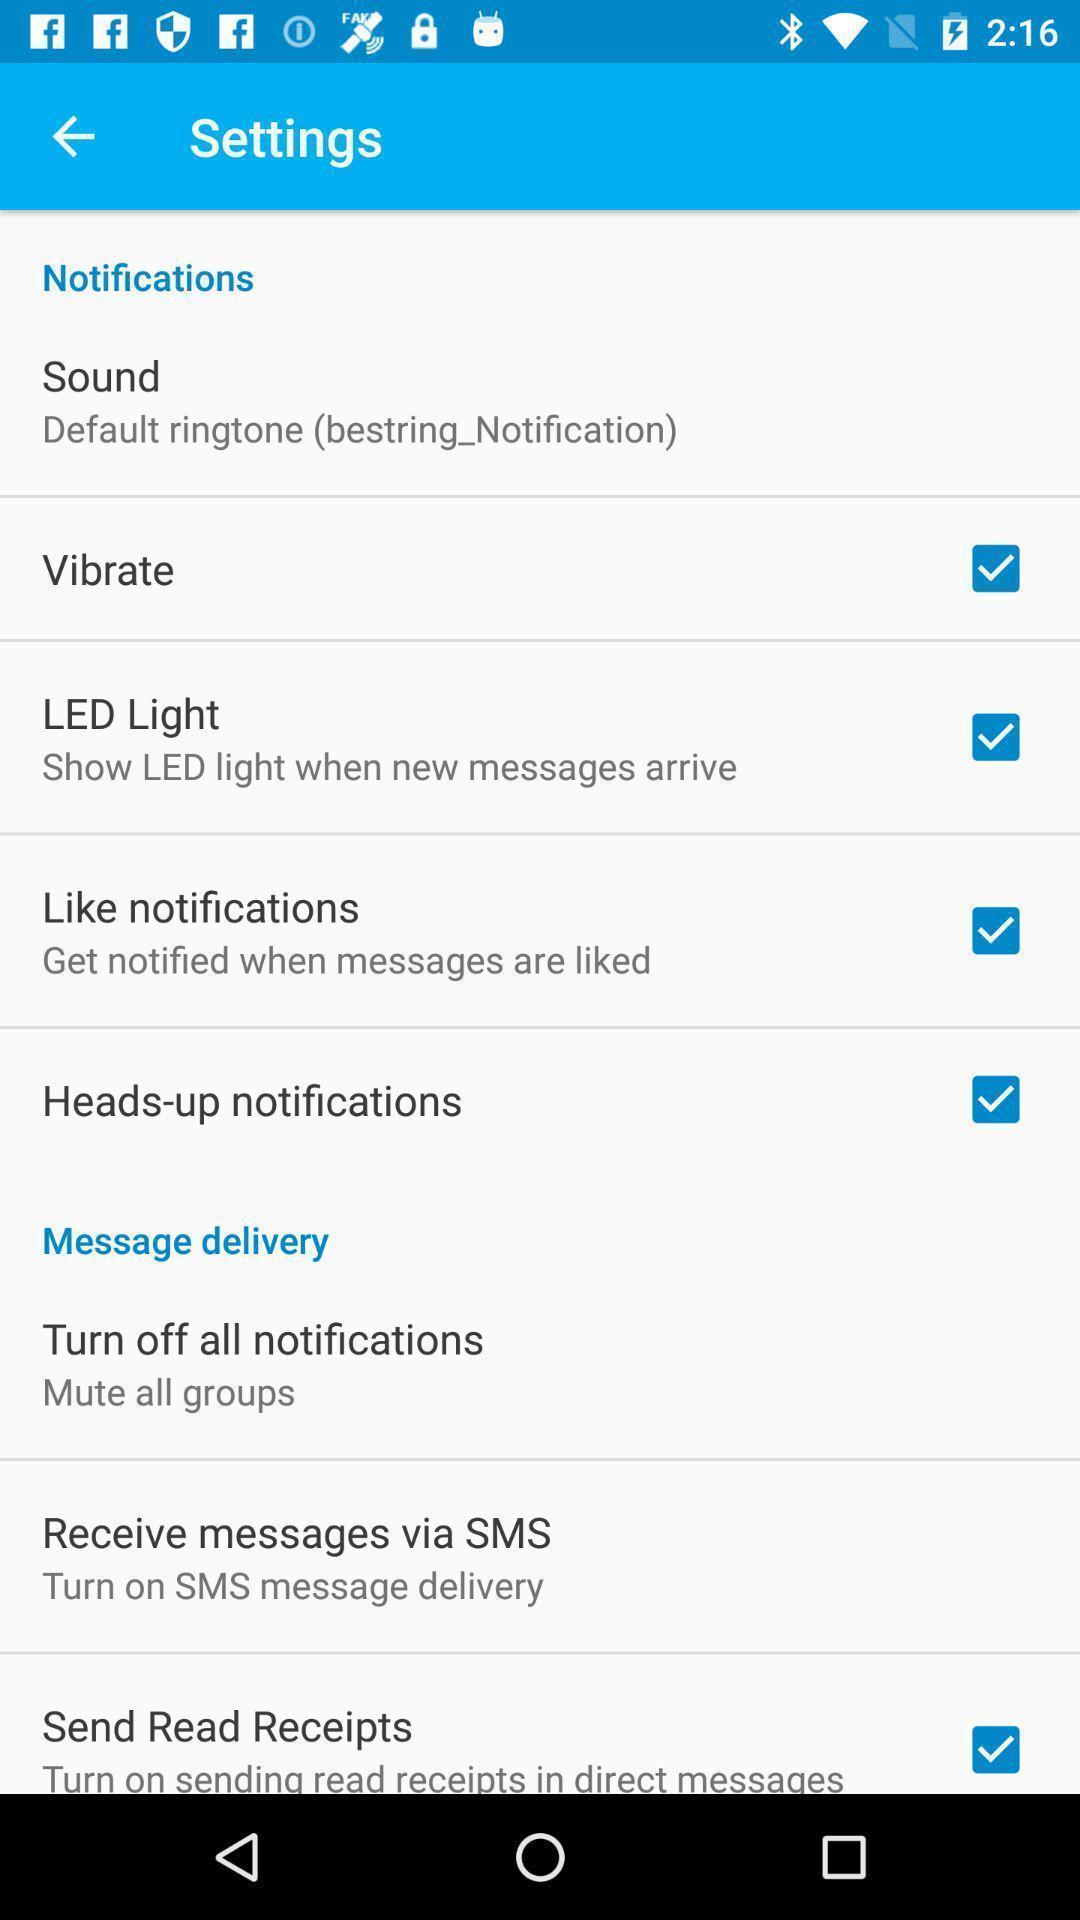Tell me what you see in this picture. Screen shows different settings in a device. 